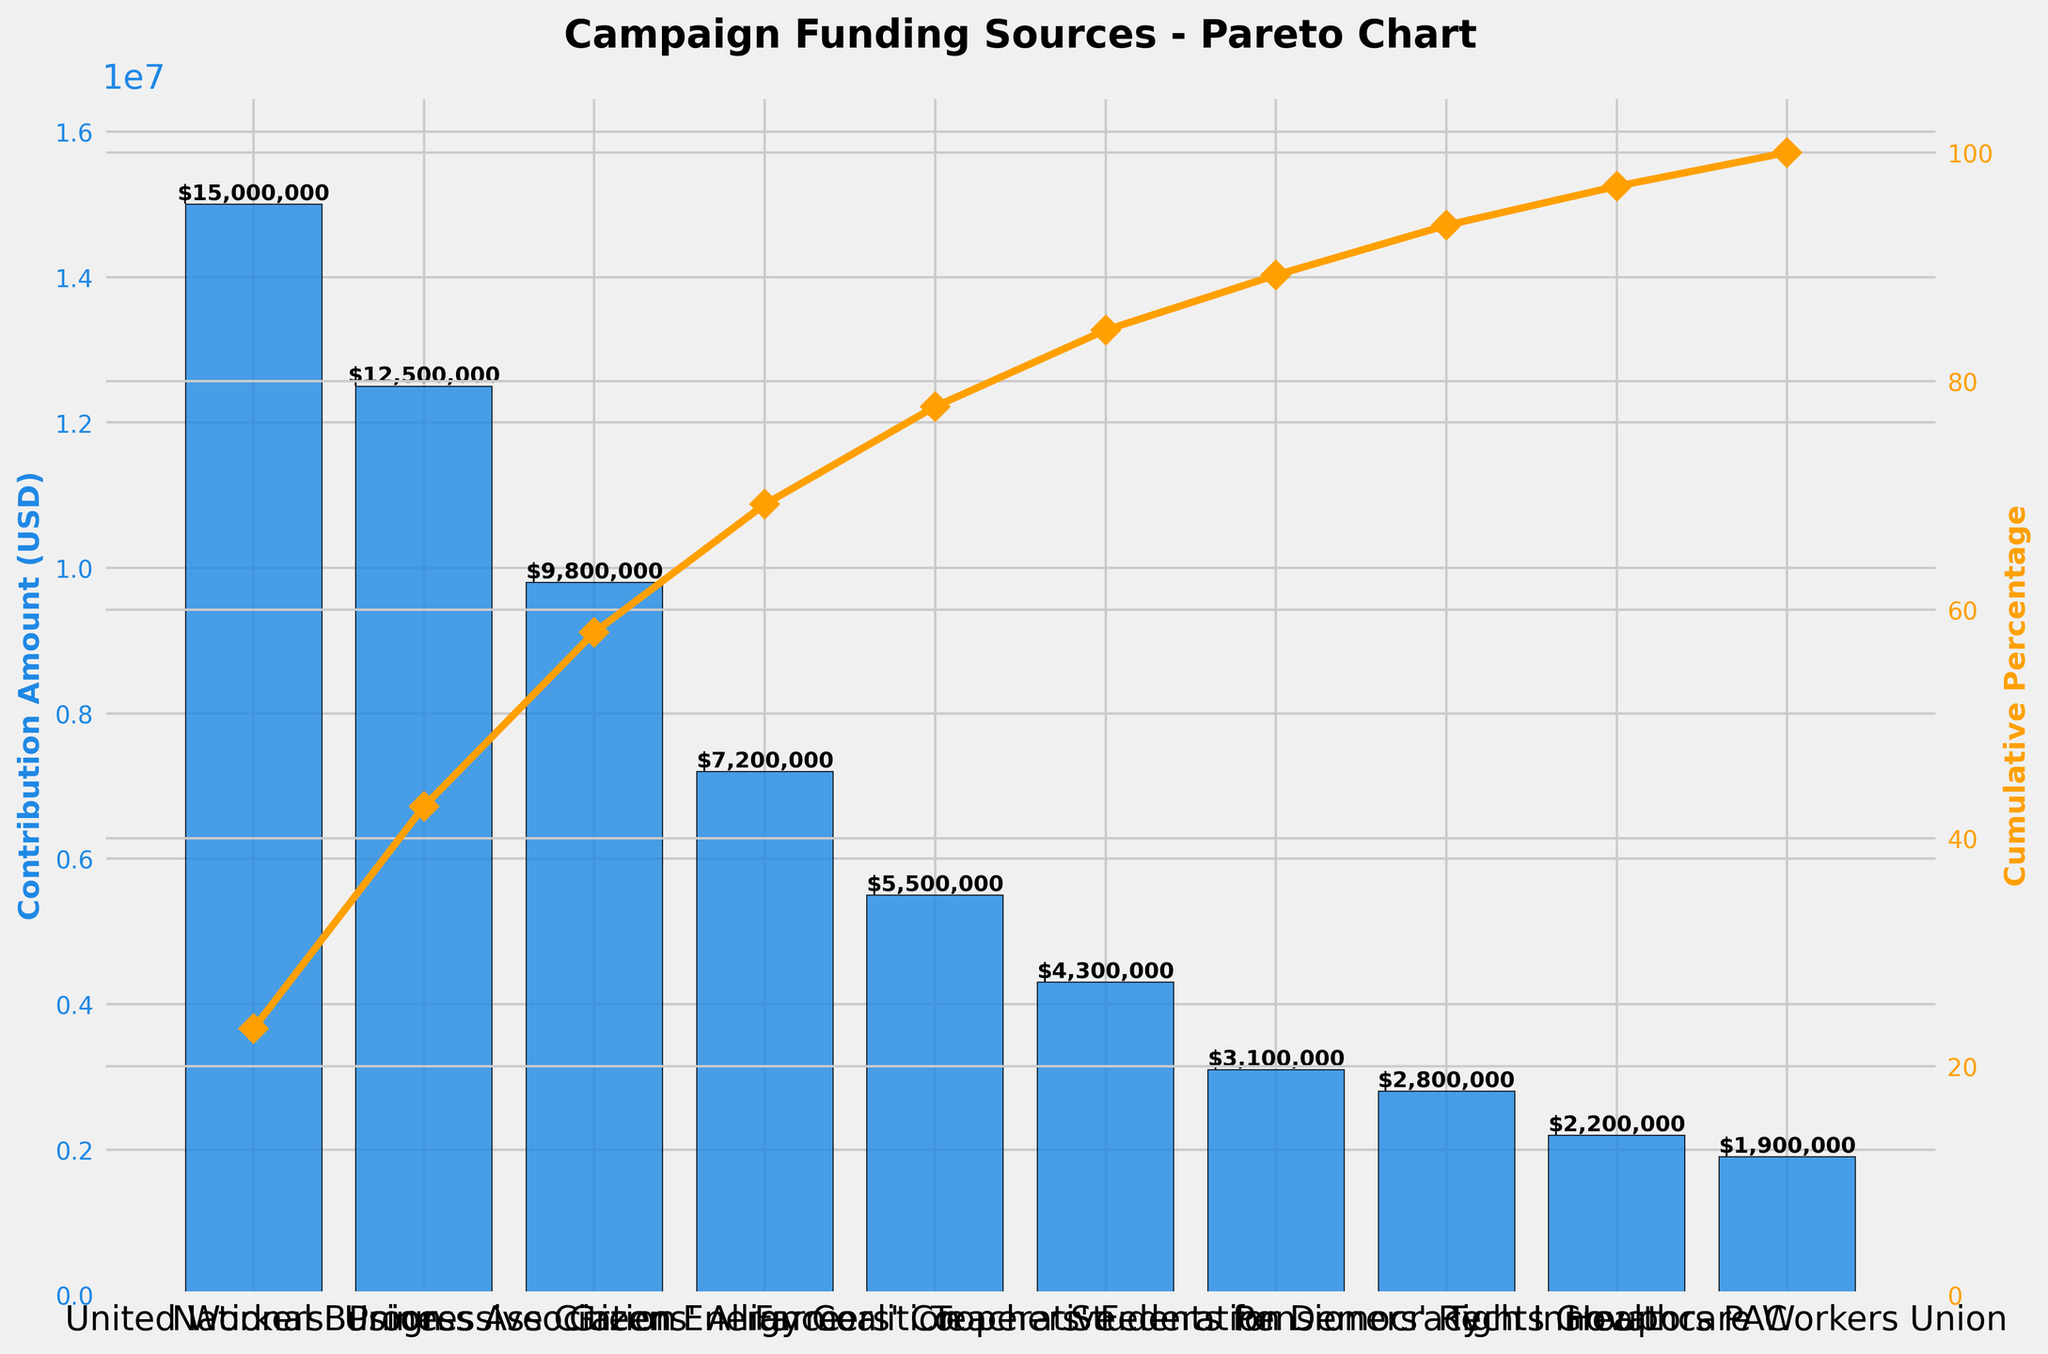What is the title of the figure? The question is asking about the basic visual element, which is the title of the figure. The title is typically displayed at the top of the figure.
Answer: Campaign Funding Sources - Pareto Chart Which funding source contributed the most amount of money? This question requires identifying the funding source with the highest bar in the bar chart, which is the first bar in descending order.
Answer: United Workers' Union What is the total contribution amount from all funding sources combined? The question requires adding up all the contribution amounts displayed on the bars. The total is $15,000,000 + $12,500,000 + $9,800,000 + $7,200,000 + $5,500,000 + $4,300,000 + $3,100,000 + $2,800,000 + $2,200,000 + $1,900,000.
Answer: $63,300,000 What percentage of the total contributions comes from the top three funding sources? This requires summing the contributions of the top three funding sources and calculating their percentage of the total. $$ \text{Total of top three sources} = $15,000,000 + $12,500,000 + $9,800,000 = $37,300,000 $$ $$ \text{Percentage} = \left( \frac{37,300,000}{63,300,000} \right) \times 100 \approx 58.9\% $$
Answer: 58.9% Which funding source's contribution marks the point where cumulative contributions surpass 50% of the total? Identify the funding source where the cumulative percentage first exceeds 50%. This can be seen by looking at the cumulative % line and its value labels. It surpasses 50% at $12,500,000 from the National Business Association.
Answer: National Business Association How does the contribution amount of the Farmers' Cooperative compare to that of the Tech Innovators PAC? Compare the height of the bars for the Farmers' Cooperative and Tech Innovators PAC. The Farmers' Cooperative contributed $5,500,000 while Tech Innovators PAC contributed $2,200,000.
Answer: The Farmers' Cooperative contributed $3,300,000 more What is the range of contribution amounts from the funding sources? Calculate the difference between the maximum and minimum contribution amounts. $$ \text{Range} = $15,000,000 - $1,900,000 = $13,100,000 $$
Answer: $13,100,000 What portion of the total contributions comes from the bottom five funding sources combined? Sum the contributions of the bottom five funding sources and calculate their percentage of the total. $$ \text{Total of bottom five sources} = $4,300,000 + $3,100,000 + $2,800,000 + $2,200,000 + $1,900,000 = $14,300,000 $$ $$ \text{Percentage} = \left( \frac{14,300,000}{63,300,000} \right) \times 100 \approx 22.6\% $$
Answer: 22.6% 